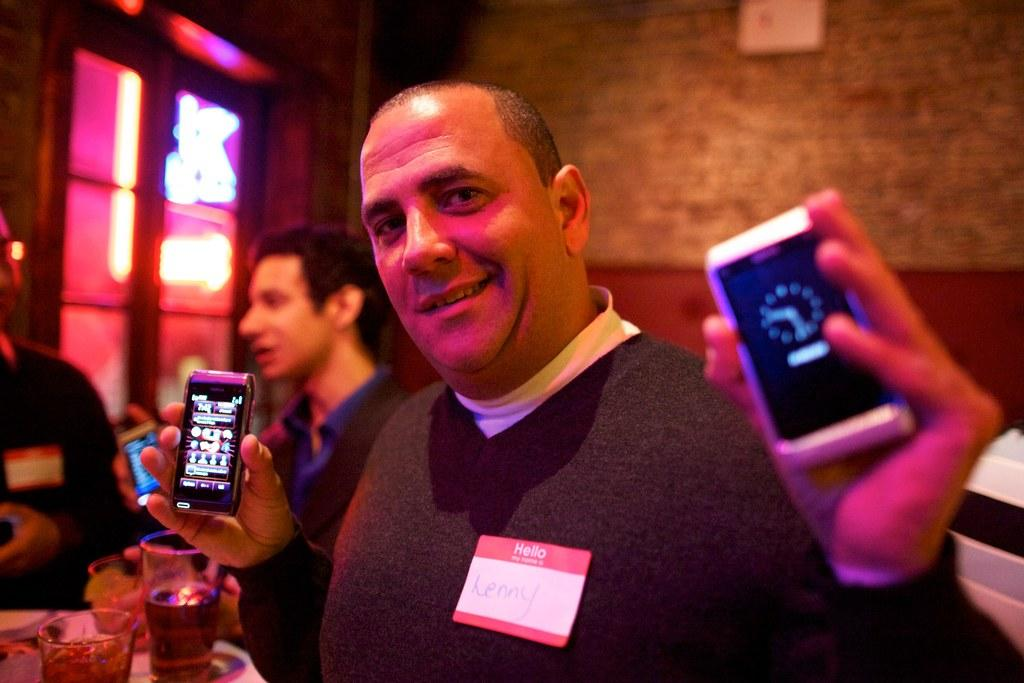Provide a one-sentence caption for the provided image. Lenny is currently at a convention and is showcasing brand new smartphones. 